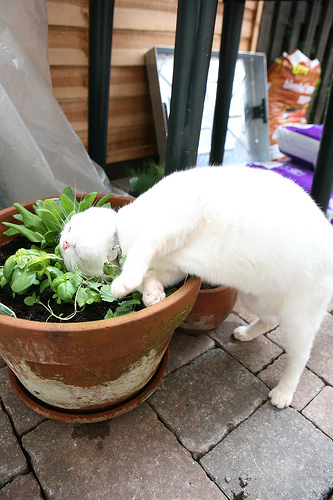What might the cat be doing with the plant? The cat appears to be investigating or playing with the plant in the pot. It might be attracted to the plant's texture or scent. Why do cats sometimes get curious about plants? Cats are naturally curious animals. They often explore their environment with their senses, and plants can be particularly intriguing due to their textures, movements, and scents. Some plants might mimic the feeling of grass, which cats have a natural instinct to chew on for digestion aid. 